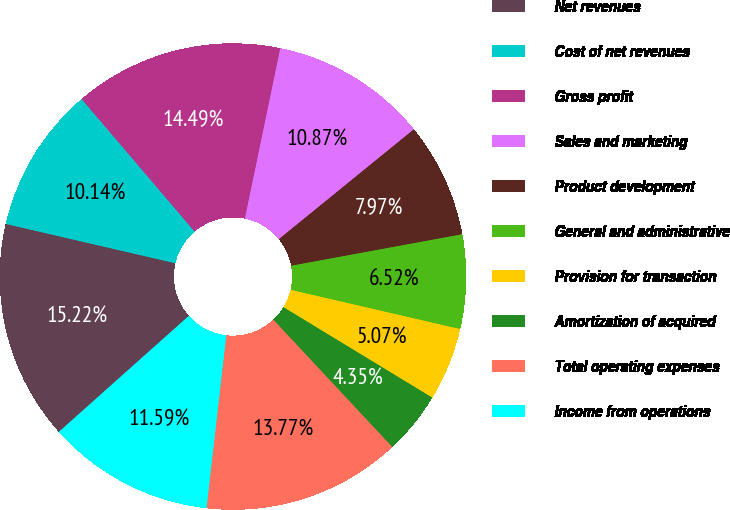Convert chart. <chart><loc_0><loc_0><loc_500><loc_500><pie_chart><fcel>Net revenues<fcel>Cost of net revenues<fcel>Gross profit<fcel>Sales and marketing<fcel>Product development<fcel>General and administrative<fcel>Provision for transaction<fcel>Amortization of acquired<fcel>Total operating expenses<fcel>Income from operations<nl><fcel>15.22%<fcel>10.14%<fcel>14.49%<fcel>10.87%<fcel>7.97%<fcel>6.52%<fcel>5.07%<fcel>4.35%<fcel>13.77%<fcel>11.59%<nl></chart> 